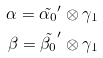Convert formula to latex. <formula><loc_0><loc_0><loc_500><loc_500>\alpha = \tilde { \alpha _ { 0 } } ^ { \prime } \otimes \gamma _ { 1 } \\ \beta = \tilde { \beta _ { 0 } } ^ { \prime } \otimes \gamma _ { 1 }</formula> 